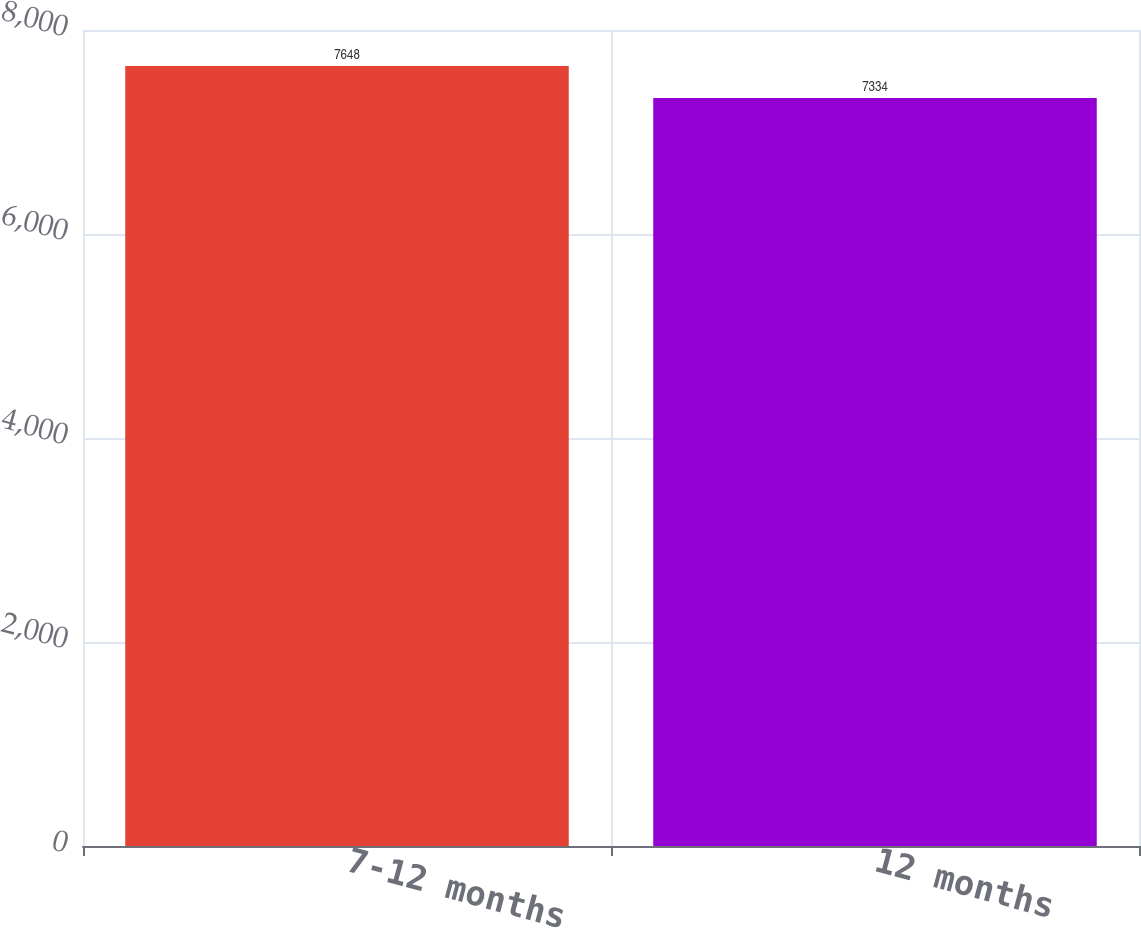<chart> <loc_0><loc_0><loc_500><loc_500><bar_chart><fcel>7-12 months<fcel>12 months<nl><fcel>7648<fcel>7334<nl></chart> 